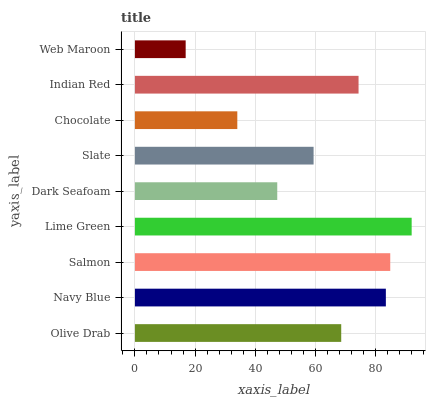Is Web Maroon the minimum?
Answer yes or no. Yes. Is Lime Green the maximum?
Answer yes or no. Yes. Is Navy Blue the minimum?
Answer yes or no. No. Is Navy Blue the maximum?
Answer yes or no. No. Is Navy Blue greater than Olive Drab?
Answer yes or no. Yes. Is Olive Drab less than Navy Blue?
Answer yes or no. Yes. Is Olive Drab greater than Navy Blue?
Answer yes or no. No. Is Navy Blue less than Olive Drab?
Answer yes or no. No. Is Olive Drab the high median?
Answer yes or no. Yes. Is Olive Drab the low median?
Answer yes or no. Yes. Is Slate the high median?
Answer yes or no. No. Is Web Maroon the low median?
Answer yes or no. No. 